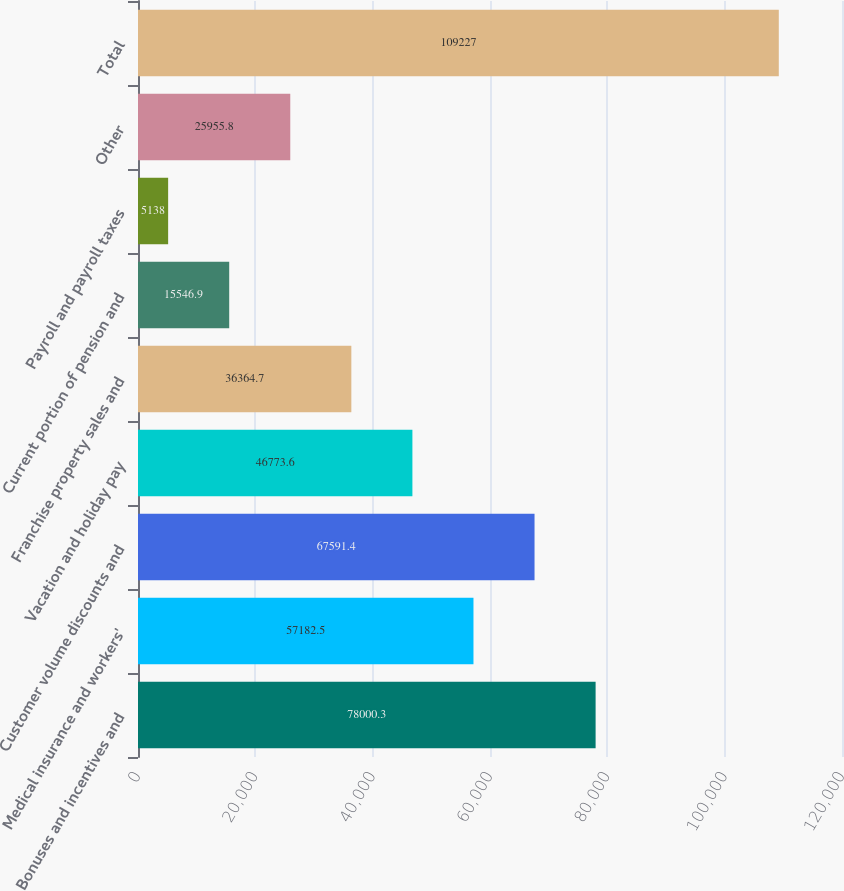Convert chart. <chart><loc_0><loc_0><loc_500><loc_500><bar_chart><fcel>Bonuses and incentives and<fcel>Medical insurance and workers'<fcel>Customer volume discounts and<fcel>Vacation and holiday pay<fcel>Franchise property sales and<fcel>Current portion of pension and<fcel>Payroll and payroll taxes<fcel>Other<fcel>Total<nl><fcel>78000.3<fcel>57182.5<fcel>67591.4<fcel>46773.6<fcel>36364.7<fcel>15546.9<fcel>5138<fcel>25955.8<fcel>109227<nl></chart> 